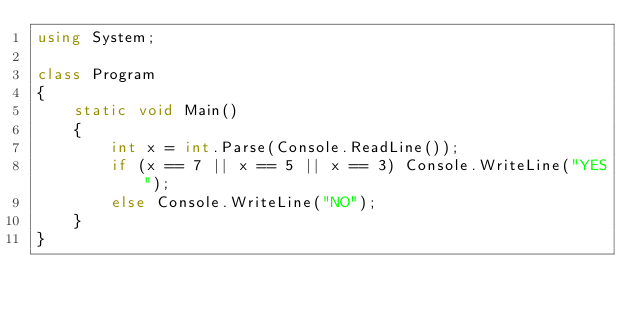<code> <loc_0><loc_0><loc_500><loc_500><_C#_>using System;

class Program
{
    static void Main()
    {
        int x = int.Parse(Console.ReadLine());
        if (x == 7 || x == 5 || x == 3) Console.WriteLine("YES");
        else Console.WriteLine("NO");
    }
}</code> 